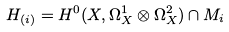<formula> <loc_0><loc_0><loc_500><loc_500>H _ { ( i ) } = H ^ { 0 } ( X , \Omega ^ { 1 } _ { X } \otimes \Omega ^ { 2 } _ { X } ) \cap M _ { i }</formula> 